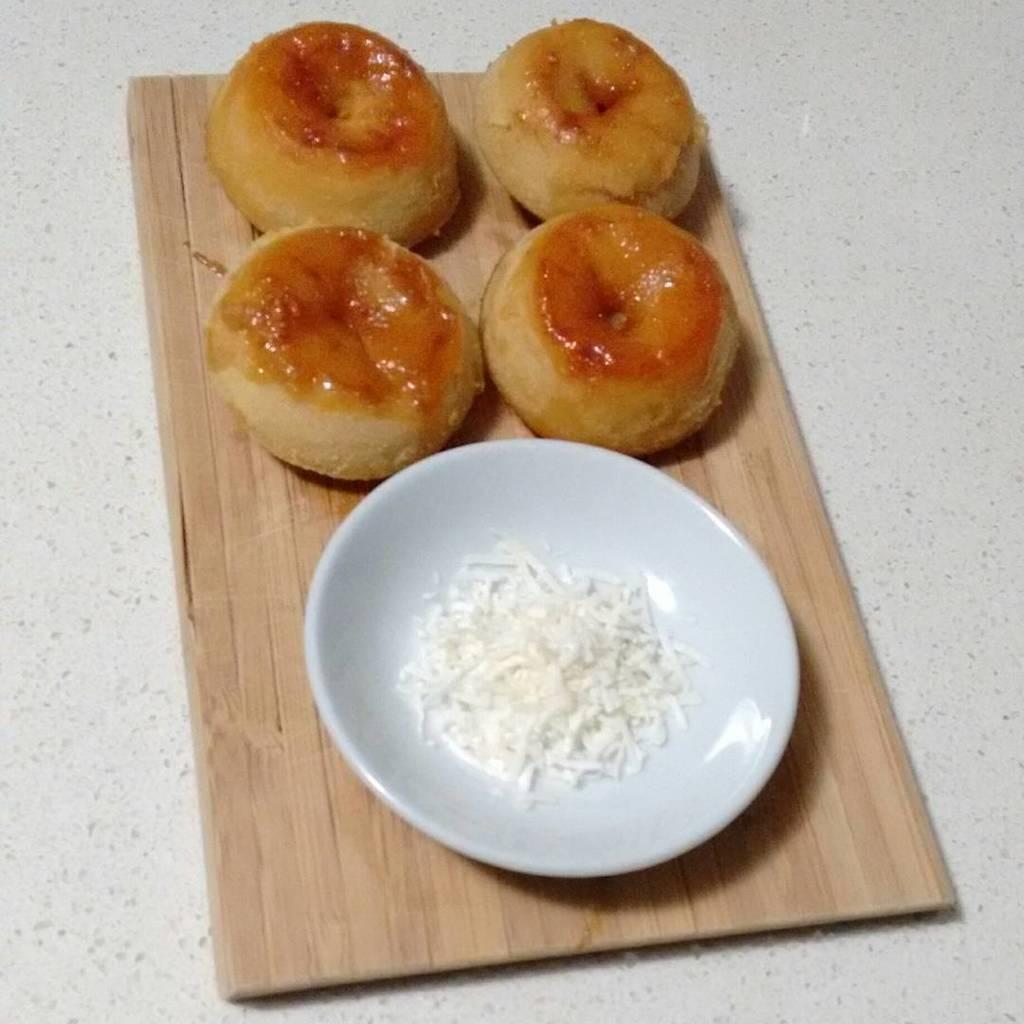Please provide a concise description of this image. In this picture we can see a white plate and some food items on a wooden object. 